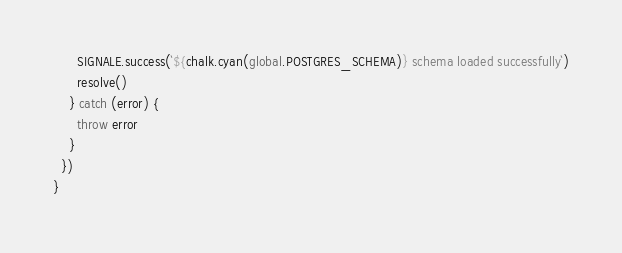Convert code to text. <code><loc_0><loc_0><loc_500><loc_500><_JavaScript_>      SIGNALE.success(`${chalk.cyan(global.POSTGRES_SCHEMA)} schema loaded successfully`)
      resolve()
    } catch (error) {
      throw error
    }
  })
}
</code> 